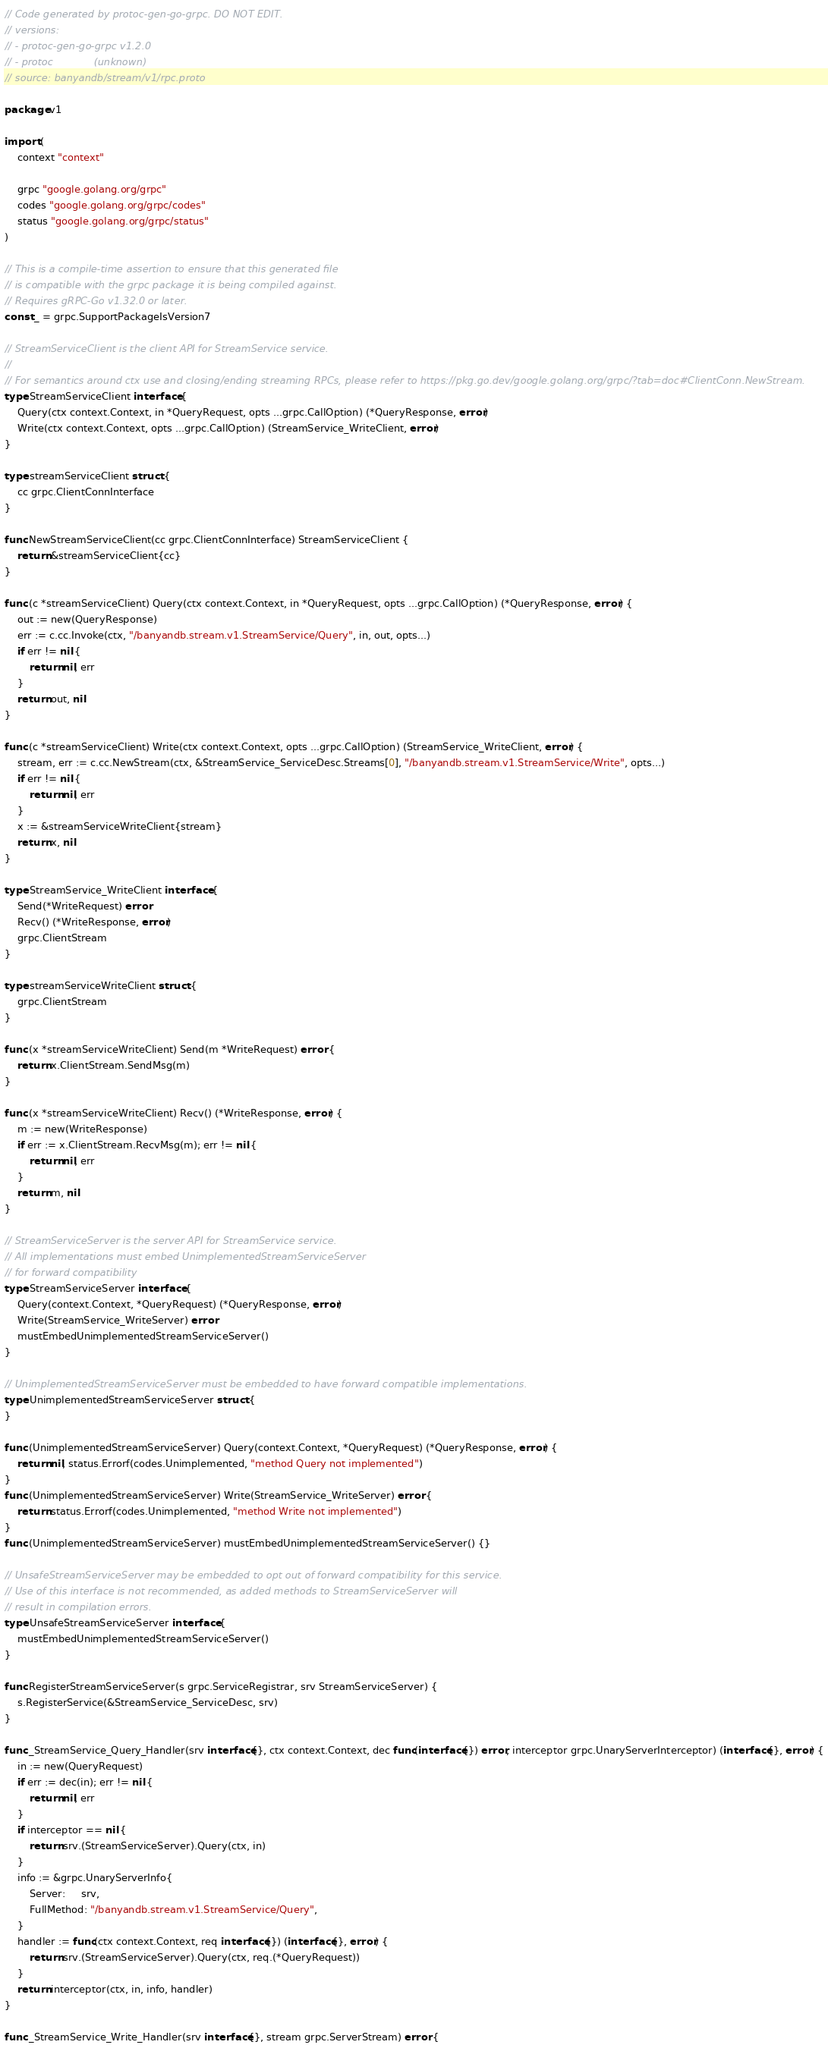Convert code to text. <code><loc_0><loc_0><loc_500><loc_500><_Go_>// Code generated by protoc-gen-go-grpc. DO NOT EDIT.
// versions:
// - protoc-gen-go-grpc v1.2.0
// - protoc             (unknown)
// source: banyandb/stream/v1/rpc.proto

package v1

import (
	context "context"

	grpc "google.golang.org/grpc"
	codes "google.golang.org/grpc/codes"
	status "google.golang.org/grpc/status"
)

// This is a compile-time assertion to ensure that this generated file
// is compatible with the grpc package it is being compiled against.
// Requires gRPC-Go v1.32.0 or later.
const _ = grpc.SupportPackageIsVersion7

// StreamServiceClient is the client API for StreamService service.
//
// For semantics around ctx use and closing/ending streaming RPCs, please refer to https://pkg.go.dev/google.golang.org/grpc/?tab=doc#ClientConn.NewStream.
type StreamServiceClient interface {
	Query(ctx context.Context, in *QueryRequest, opts ...grpc.CallOption) (*QueryResponse, error)
	Write(ctx context.Context, opts ...grpc.CallOption) (StreamService_WriteClient, error)
}

type streamServiceClient struct {
	cc grpc.ClientConnInterface
}

func NewStreamServiceClient(cc grpc.ClientConnInterface) StreamServiceClient {
	return &streamServiceClient{cc}
}

func (c *streamServiceClient) Query(ctx context.Context, in *QueryRequest, opts ...grpc.CallOption) (*QueryResponse, error) {
	out := new(QueryResponse)
	err := c.cc.Invoke(ctx, "/banyandb.stream.v1.StreamService/Query", in, out, opts...)
	if err != nil {
		return nil, err
	}
	return out, nil
}

func (c *streamServiceClient) Write(ctx context.Context, opts ...grpc.CallOption) (StreamService_WriteClient, error) {
	stream, err := c.cc.NewStream(ctx, &StreamService_ServiceDesc.Streams[0], "/banyandb.stream.v1.StreamService/Write", opts...)
	if err != nil {
		return nil, err
	}
	x := &streamServiceWriteClient{stream}
	return x, nil
}

type StreamService_WriteClient interface {
	Send(*WriteRequest) error
	Recv() (*WriteResponse, error)
	grpc.ClientStream
}

type streamServiceWriteClient struct {
	grpc.ClientStream
}

func (x *streamServiceWriteClient) Send(m *WriteRequest) error {
	return x.ClientStream.SendMsg(m)
}

func (x *streamServiceWriteClient) Recv() (*WriteResponse, error) {
	m := new(WriteResponse)
	if err := x.ClientStream.RecvMsg(m); err != nil {
		return nil, err
	}
	return m, nil
}

// StreamServiceServer is the server API for StreamService service.
// All implementations must embed UnimplementedStreamServiceServer
// for forward compatibility
type StreamServiceServer interface {
	Query(context.Context, *QueryRequest) (*QueryResponse, error)
	Write(StreamService_WriteServer) error
	mustEmbedUnimplementedStreamServiceServer()
}

// UnimplementedStreamServiceServer must be embedded to have forward compatible implementations.
type UnimplementedStreamServiceServer struct {
}

func (UnimplementedStreamServiceServer) Query(context.Context, *QueryRequest) (*QueryResponse, error) {
	return nil, status.Errorf(codes.Unimplemented, "method Query not implemented")
}
func (UnimplementedStreamServiceServer) Write(StreamService_WriteServer) error {
	return status.Errorf(codes.Unimplemented, "method Write not implemented")
}
func (UnimplementedStreamServiceServer) mustEmbedUnimplementedStreamServiceServer() {}

// UnsafeStreamServiceServer may be embedded to opt out of forward compatibility for this service.
// Use of this interface is not recommended, as added methods to StreamServiceServer will
// result in compilation errors.
type UnsafeStreamServiceServer interface {
	mustEmbedUnimplementedStreamServiceServer()
}

func RegisterStreamServiceServer(s grpc.ServiceRegistrar, srv StreamServiceServer) {
	s.RegisterService(&StreamService_ServiceDesc, srv)
}

func _StreamService_Query_Handler(srv interface{}, ctx context.Context, dec func(interface{}) error, interceptor grpc.UnaryServerInterceptor) (interface{}, error) {
	in := new(QueryRequest)
	if err := dec(in); err != nil {
		return nil, err
	}
	if interceptor == nil {
		return srv.(StreamServiceServer).Query(ctx, in)
	}
	info := &grpc.UnaryServerInfo{
		Server:     srv,
		FullMethod: "/banyandb.stream.v1.StreamService/Query",
	}
	handler := func(ctx context.Context, req interface{}) (interface{}, error) {
		return srv.(StreamServiceServer).Query(ctx, req.(*QueryRequest))
	}
	return interceptor(ctx, in, info, handler)
}

func _StreamService_Write_Handler(srv interface{}, stream grpc.ServerStream) error {</code> 